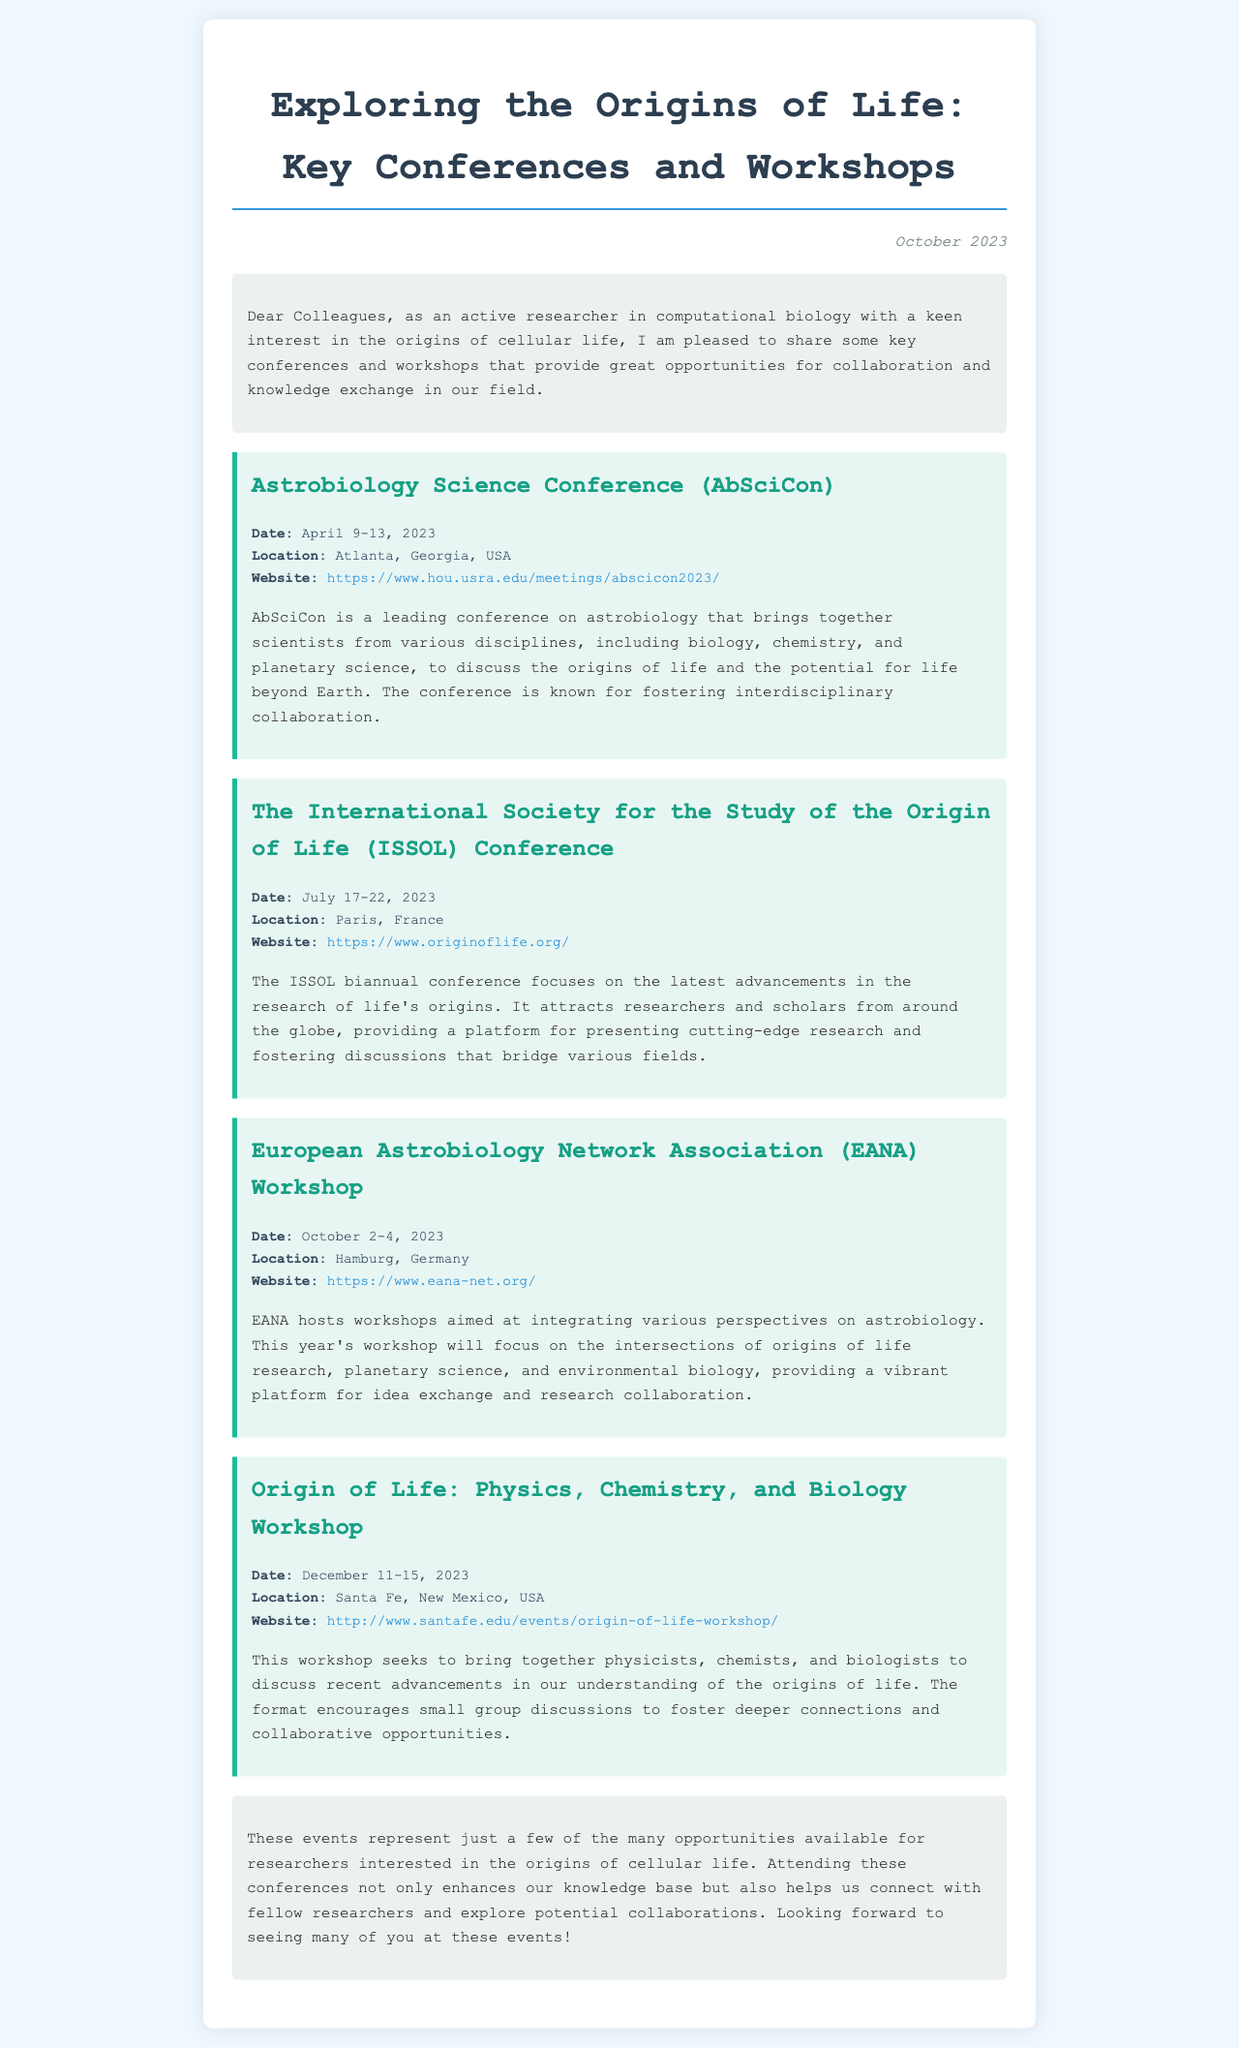What is the title of the newsletter? The title is prominently displayed at the top of the document, introducing the topic of the content.
Answer: Exploring the Origins of Life: Key Conferences and Workshops When is the AbSciCon conference scheduled? The document provides the dates for the AbSciCon conference within the event details section.
Answer: April 9-13, 2023 Where will the ISSOL conference take place? The location of the ISSOL conference is mentioned in the event details section.
Answer: Paris, France What is the focus of the EANA workshop? The document summarizes the main topic of the EANA workshop, indicating its purpose.
Answer: The intersections of origins of life research, planetary science, and environmental biology How many conferences and workshops are listed in the newsletter? The document lists four significant events under the event section.
Answer: Four What type of professionals does the Origin of Life workshop aim to bring together? The document specifies the disciplines of professionals targeted for the workshop.
Answer: Physicists, chemists, and biologists What is the date of the next scheduled event in the newsletter? The document lists event dates, and the next event date can be found in the event details.
Answer: October 2-4, 2023 What is the primary purpose of attending these events according to the conclusion? The conclusion section emphasizes the benefits of attendance for researchers.
Answer: Enhance knowledge base and connect with fellow researchers 